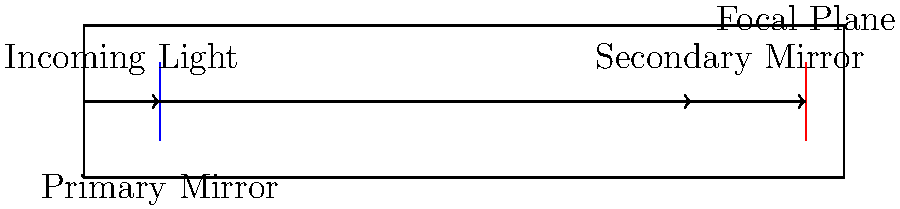In the context of implementing AI for astronomical data analysis in the justice system, consider the cross-sectional diagram of a reflecting telescope. What is the primary function of the component labeled "Secondary Mirror" in this optical system? To understand the function of the secondary mirror in a reflecting telescope, let's break down the light path:

1. Incoming light enters the telescope from the left side of the diagram.

2. The light hits the primary mirror, which is concave and reflects the light towards the front of the telescope.

3. Before reaching the focal point of the primary mirror, the light encounters the secondary mirror.

4. The secondary mirror's primary function is to redirect the light to a more convenient location for observation or instrumentation.

5. In this case, the secondary mirror reflects the light towards the focal plane at the back of the telescope.

6. This design allows for the placement of instruments or eyepieces at the focal plane without obstructing the incoming light.

7. The secondary mirror also helps in achieving a more compact telescope design, as it effectively "folds" the optical path.

8. In the context of AI implementation for astronomical data analysis, the secondary mirror plays a crucial role in directing light to detectors or cameras that capture data for AI processing.

9. The precise alignment and shape of the secondary mirror are critical for maintaining image quality and ensuring accurate data collection for AI analysis in astronomical applications.
Answer: Redirect light to the focal plane 